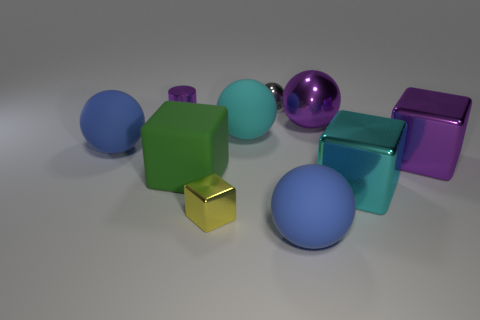Subtract 2 balls. How many balls are left? 3 Subtract all purple balls. How many balls are left? 4 Subtract all purple balls. How many balls are left? 4 Subtract all yellow balls. Subtract all cyan cubes. How many balls are left? 5 Subtract all blocks. How many objects are left? 6 Subtract 1 purple cubes. How many objects are left? 9 Subtract all big purple objects. Subtract all large green cubes. How many objects are left? 7 Add 7 small yellow metallic things. How many small yellow metallic things are left? 8 Add 5 tiny red balls. How many tiny red balls exist? 5 